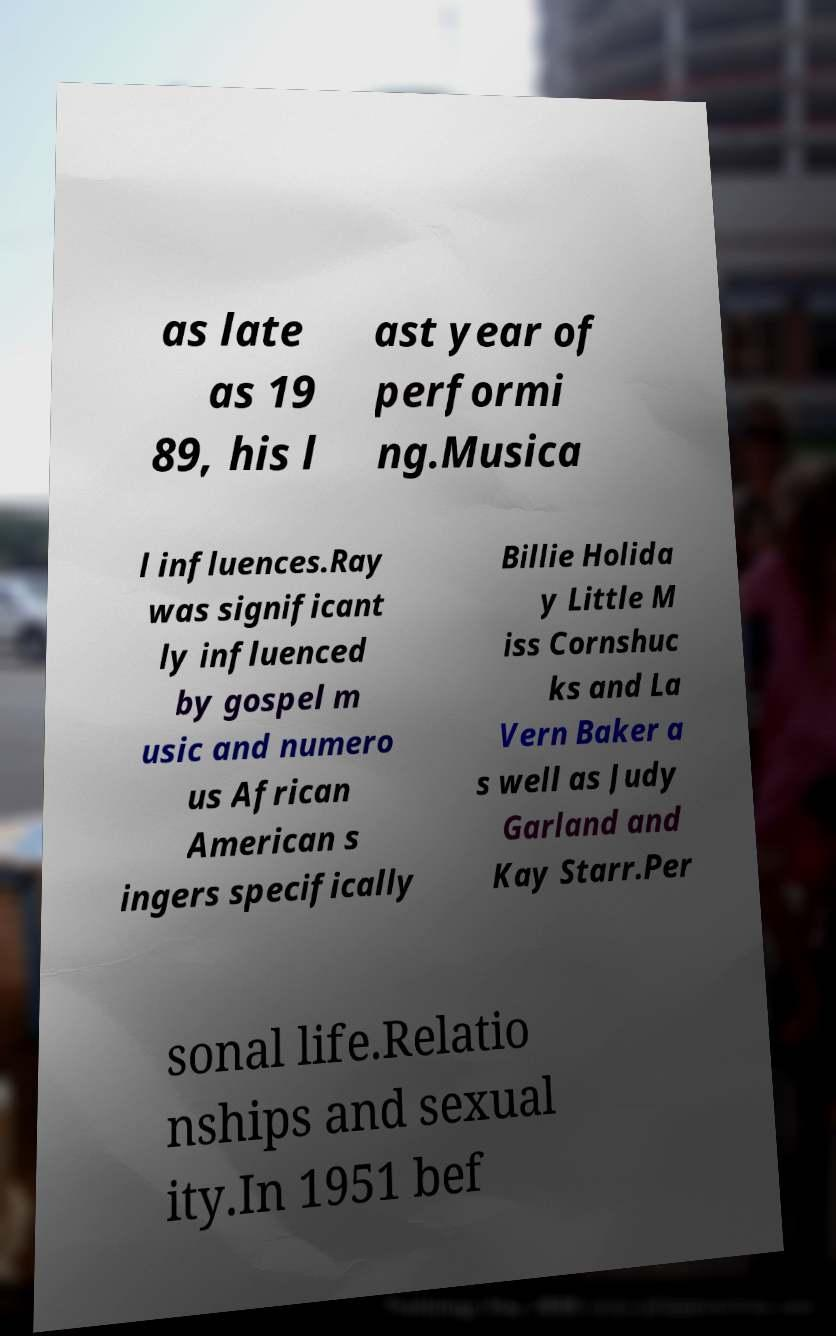Could you assist in decoding the text presented in this image and type it out clearly? as late as 19 89, his l ast year of performi ng.Musica l influences.Ray was significant ly influenced by gospel m usic and numero us African American s ingers specifically Billie Holida y Little M iss Cornshuc ks and La Vern Baker a s well as Judy Garland and Kay Starr.Per sonal life.Relatio nships and sexual ity.In 1951 bef 